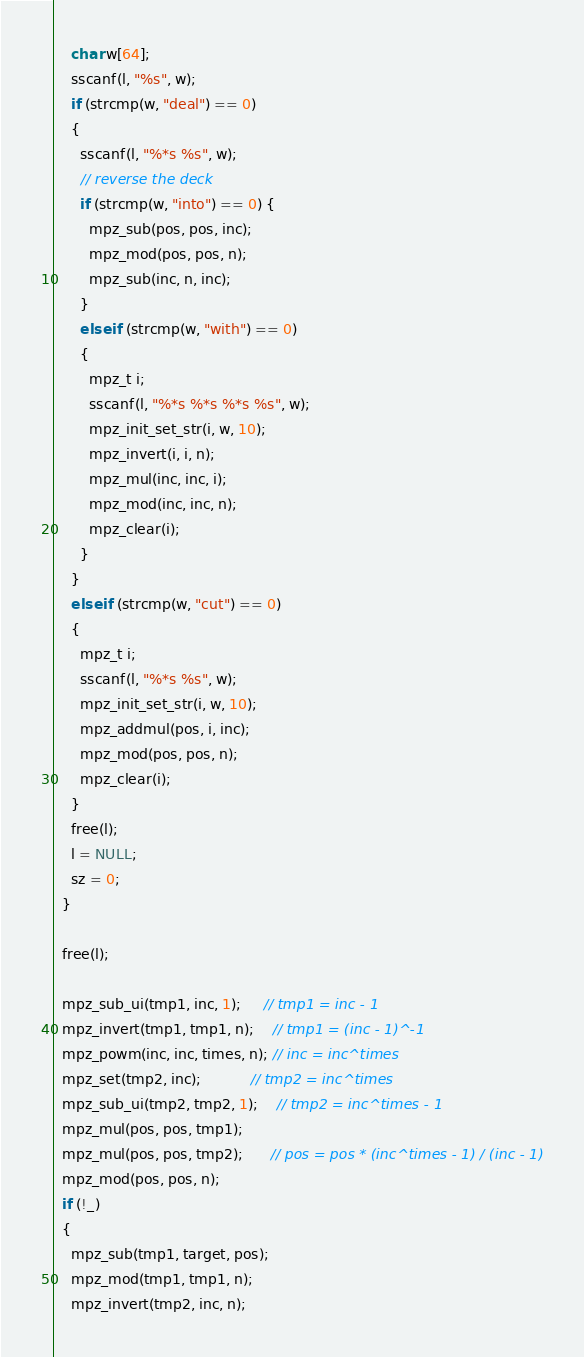Convert code to text. <code><loc_0><loc_0><loc_500><loc_500><_C_>    char w[64];
    sscanf(l, "%s", w);
    if (strcmp(w, "deal") == 0)
    {
      sscanf(l, "%*s %s", w);
      // reverse the deck
      if (strcmp(w, "into") == 0) {
        mpz_sub(pos, pos, inc);
        mpz_mod(pos, pos, n);
        mpz_sub(inc, n, inc);
      }
      else if (strcmp(w, "with") == 0)
      {
        mpz_t i;
        sscanf(l, "%*s %*s %*s %s", w);
        mpz_init_set_str(i, w, 10);
        mpz_invert(i, i, n);
        mpz_mul(inc, inc, i);
        mpz_mod(inc, inc, n);
        mpz_clear(i);
      }
    }
    else if (strcmp(w, "cut") == 0)
    {
      mpz_t i;
      sscanf(l, "%*s %s", w);
      mpz_init_set_str(i, w, 10);
      mpz_addmul(pos, i, inc);
      mpz_mod(pos, pos, n);
      mpz_clear(i);
    }
    free(l);
    l = NULL;
    sz = 0;
  }

  free(l);

  mpz_sub_ui(tmp1, inc, 1);     // tmp1 = inc - 1
  mpz_invert(tmp1, tmp1, n);    // tmp1 = (inc - 1)^-1
  mpz_powm(inc, inc, times, n); // inc = inc^times
  mpz_set(tmp2, inc);           // tmp2 = inc^times
  mpz_sub_ui(tmp2, tmp2, 1);    // tmp2 = inc^times - 1
  mpz_mul(pos, pos, tmp1);
  mpz_mul(pos, pos, tmp2);      // pos = pos * (inc^times - 1) / (inc - 1)
  mpz_mod(pos, pos, n);
  if (!_)
  {
    mpz_sub(tmp1, target, pos);
    mpz_mod(tmp1, tmp1, n);
    mpz_invert(tmp2, inc, n);</code> 